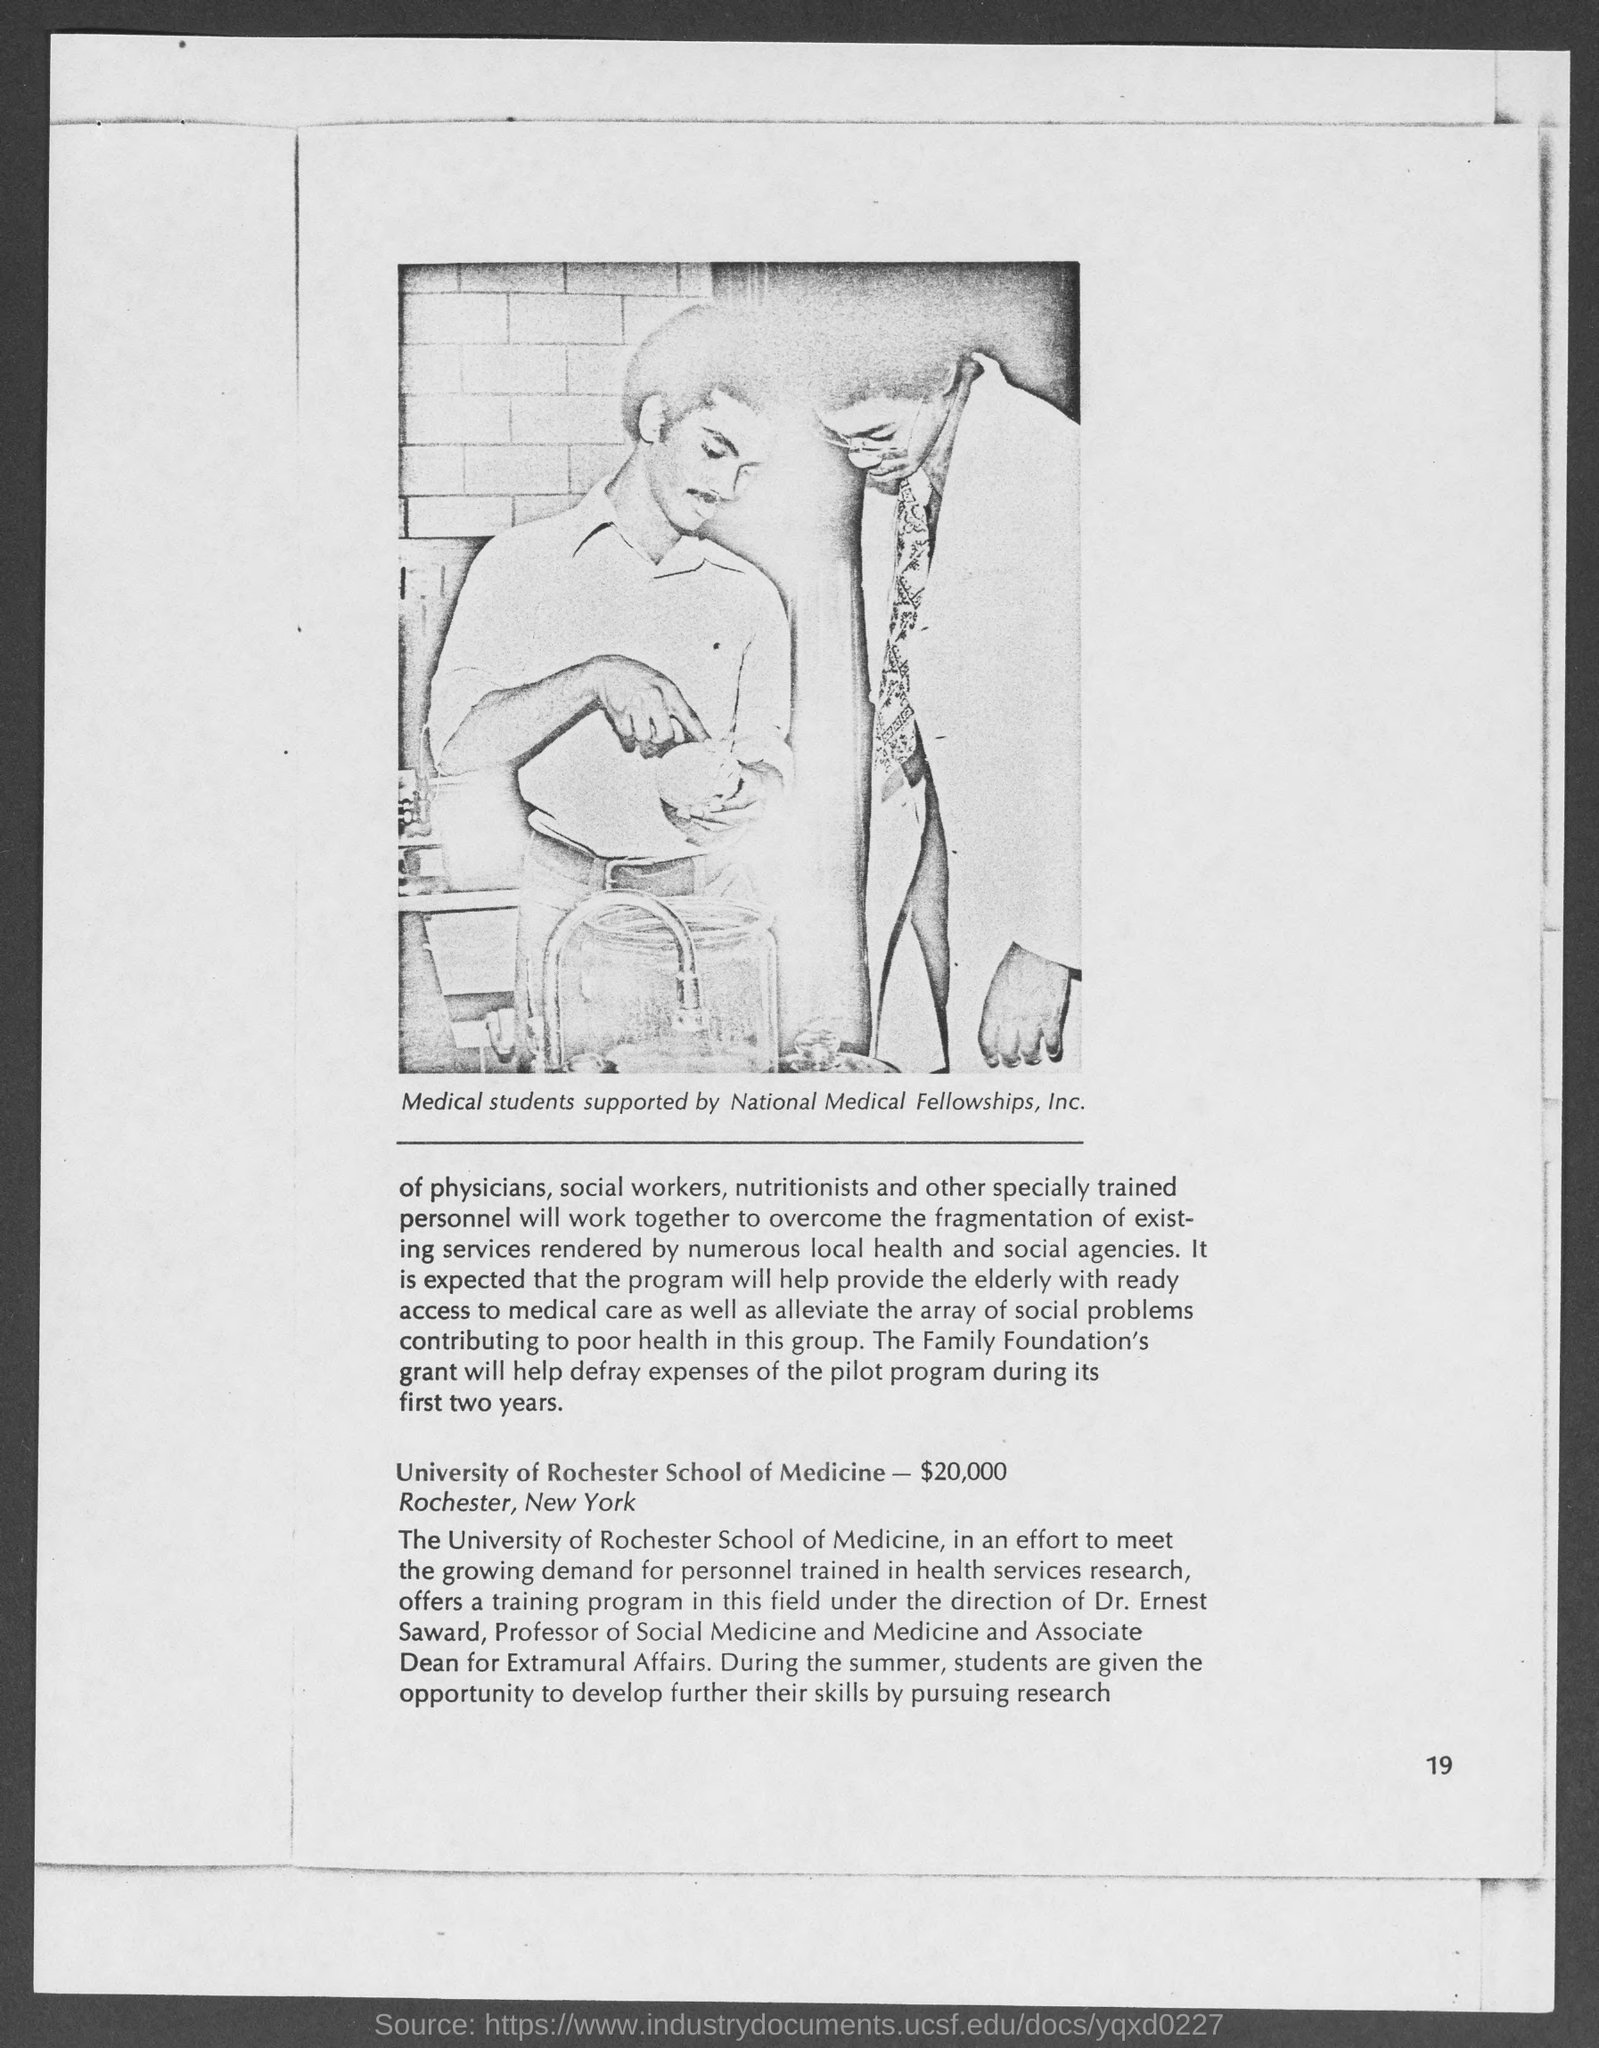Where is the University of Rochester School of Medicine?
Your response must be concise. Rochester, New York. 